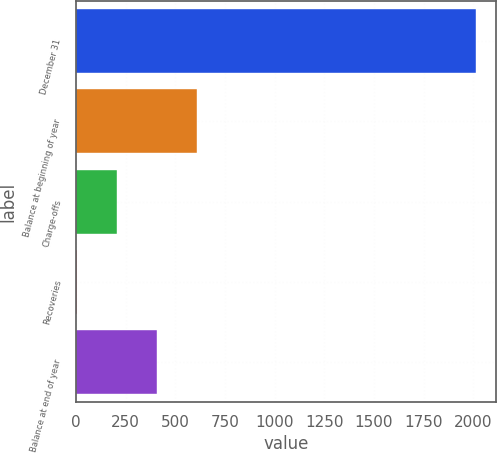Convert chart to OTSL. <chart><loc_0><loc_0><loc_500><loc_500><bar_chart><fcel>December 31<fcel>Balance at beginning of year<fcel>Charge-offs<fcel>Recoveries<fcel>Balance at end of year<nl><fcel>2013<fcel>606.7<fcel>204.9<fcel>4<fcel>405.8<nl></chart> 